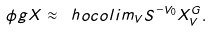<formula> <loc_0><loc_0><loc_500><loc_500>\phi g X \approx \ h o c o l i m _ { V } S ^ { - V _ { 0 } } X _ { V } ^ { G } .</formula> 